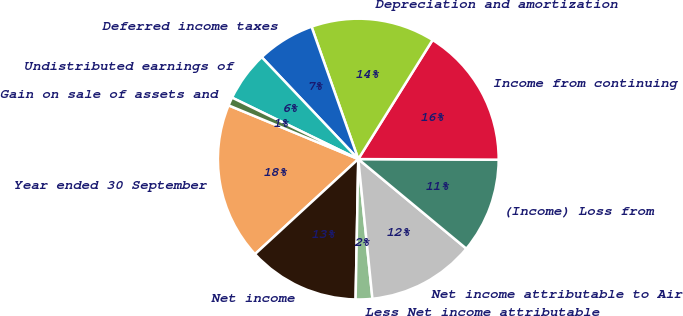Convert chart. <chart><loc_0><loc_0><loc_500><loc_500><pie_chart><fcel>Year ended 30 September<fcel>Net income<fcel>Less Net income attributable<fcel>Net income attributable to Air<fcel>(Income) Loss from<fcel>Income from continuing<fcel>Depreciation and amortization<fcel>Deferred income taxes<fcel>Undistributed earnings of<fcel>Gain on sale of assets and<nl><fcel>18.09%<fcel>12.86%<fcel>1.91%<fcel>12.38%<fcel>10.95%<fcel>16.19%<fcel>14.28%<fcel>6.67%<fcel>5.72%<fcel>0.96%<nl></chart> 